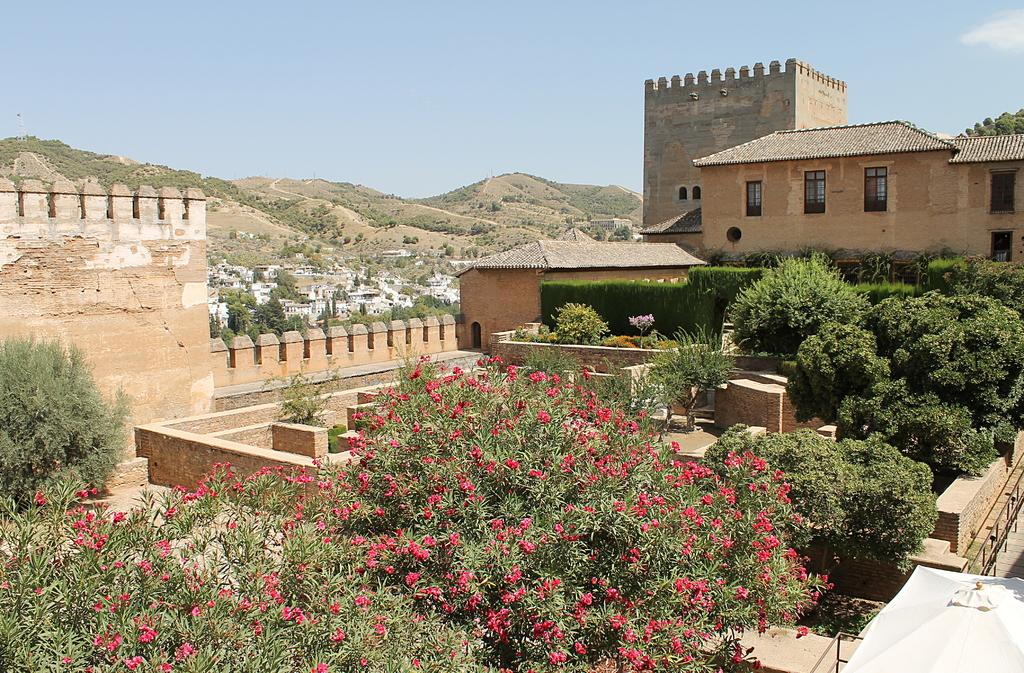What type of structures can be seen in the image? There are buildings in the image. What natural elements are present in the image? There are trees and flowers in the image. What type of temporary shelter is visible in the image? There is a tent in the image. What geographical feature can be seen in the background of the image? There are mountains in the image. What part of the natural environment is visible in the image? The sky is visible in the image. What type of volleyball court can be seen in the image? There is no volleyball court present in the image. Can you tell me which judge is presiding over the case in the image? There is no courtroom or judge depicted in the image. What type of religious symbol can be seen in the image? There is no religious symbol present in the image. 